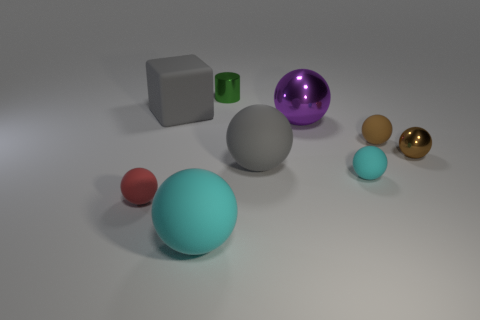There is another sphere that is the same color as the tiny shiny ball; what is its size?
Your response must be concise. Small. The big rubber object that is the same color as the block is what shape?
Ensure brevity in your answer.  Sphere. What is the small sphere that is to the left of the big gray cube made of?
Your answer should be very brief. Rubber. Do the cyan sphere that is left of the tiny green metal cylinder and the cyan matte ball right of the cylinder have the same size?
Provide a succinct answer. No. What is the color of the tiny shiny ball?
Your response must be concise. Brown. Is the shape of the cyan matte thing that is on the right side of the tiny green object the same as  the tiny red object?
Ensure brevity in your answer.  Yes. What is the purple sphere made of?
Your response must be concise. Metal. The red rubber thing that is the same size as the brown matte thing is what shape?
Make the answer very short. Sphere. Is there a sphere that has the same color as the big block?
Keep it short and to the point. Yes. Does the large block have the same color as the large rubber sphere that is behind the small red rubber sphere?
Give a very brief answer. Yes. 